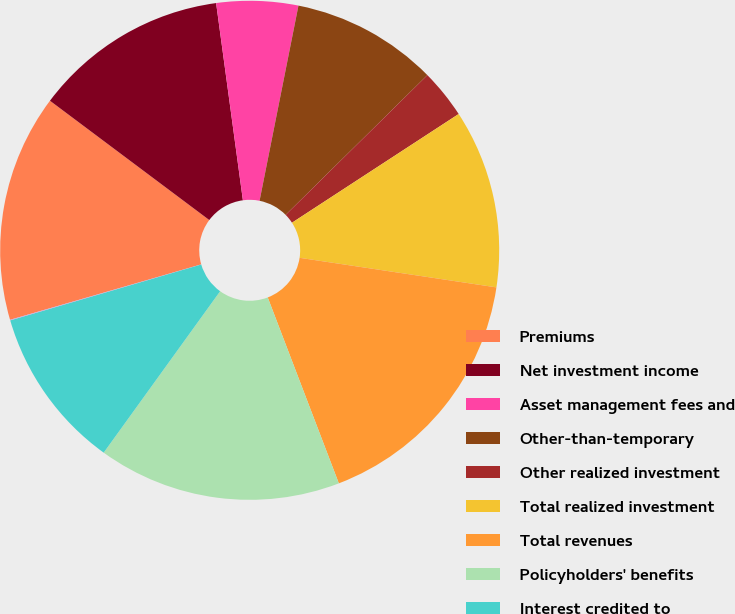<chart> <loc_0><loc_0><loc_500><loc_500><pie_chart><fcel>Premiums<fcel>Net investment income<fcel>Asset management fees and<fcel>Other-than-temporary<fcel>Other realized investment<fcel>Total realized investment<fcel>Total revenues<fcel>Policyholders' benefits<fcel>Interest credited to<fcel>Dividends to policyholders<nl><fcel>14.72%<fcel>12.62%<fcel>5.28%<fcel>9.48%<fcel>3.19%<fcel>11.57%<fcel>16.81%<fcel>15.76%<fcel>10.52%<fcel>0.04%<nl></chart> 